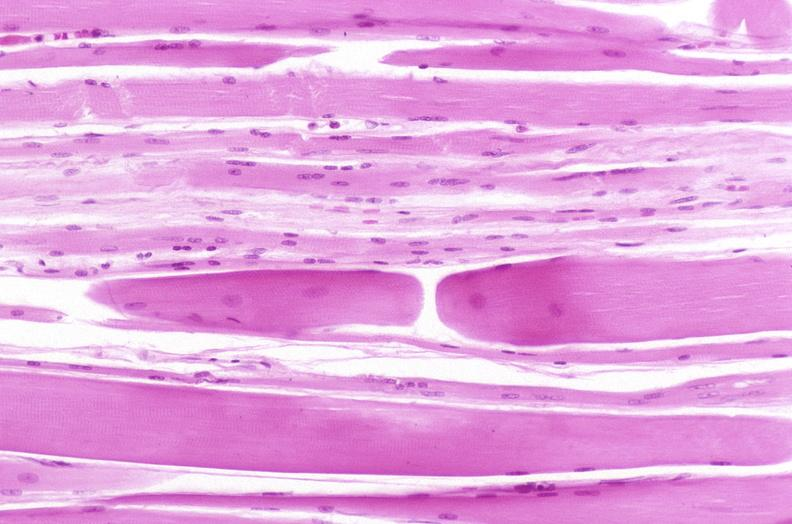why does this image show skeletal muscle, atrophy?
Answer the question using a single word or phrase. Due to immobilization cast 